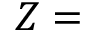<formula> <loc_0><loc_0><loc_500><loc_500>Z =</formula> 